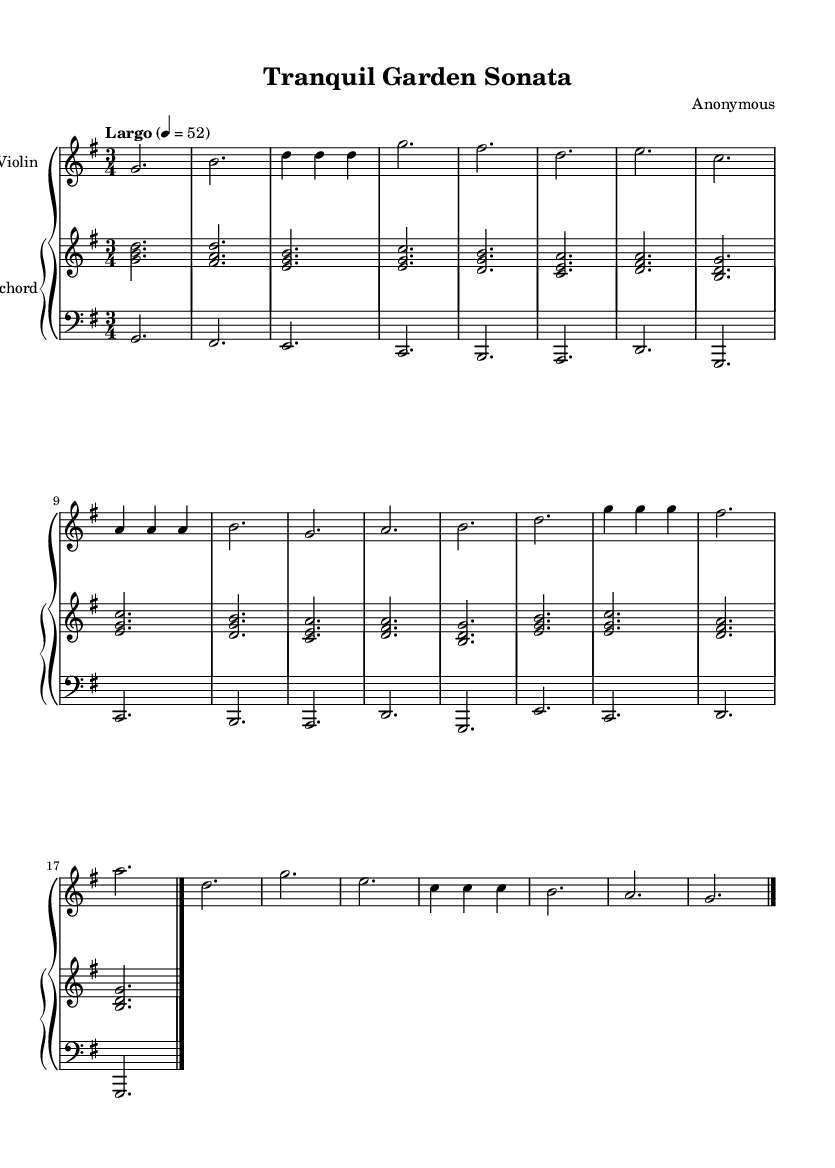What is the key signature of this music? The key signature is G major, which has one sharp (F#). This can be determined by identifying the key signature at the beginning of the staff, looking for any sharps or flats.
Answer: G major What is the time signature of this music? The time signature is 3/4, indicated at the beginning of the score with a "3" on top of a "4." This means there are three beats per measure and the quarter note gets one beat.
Answer: 3/4 What is the tempo marking of the piece? The tempo marking is "Largo," which is situated above the staff at the beginning of the piece, indicating a slow tempo.
Answer: Largo How many total measures are in the piece? There are 16 measures in total, which can be counted by observing the endings and the bar lines throughout the score.
Answer: 16 What is the highest pitch in the violin part? The highest pitch in the violin part is D. This can be concluded by looking through the notes in the violin line and identifying the highest note, which is D on the fourth measure.
Answer: D Which instruments are featured in this music? The featured instruments are the violin and harpsichord. This is evident from the labels at the beginning of each staff in the score.
Answer: Violin and Harpsichord 